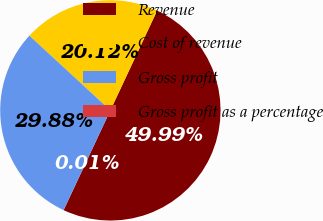Convert chart to OTSL. <chart><loc_0><loc_0><loc_500><loc_500><pie_chart><fcel>Revenue<fcel>Cost of revenue<fcel>Gross profit<fcel>Gross profit as a percentage<nl><fcel>50.0%<fcel>20.12%<fcel>29.88%<fcel>0.01%<nl></chart> 